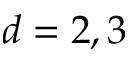<formula> <loc_0><loc_0><loc_500><loc_500>d = 2 , 3</formula> 